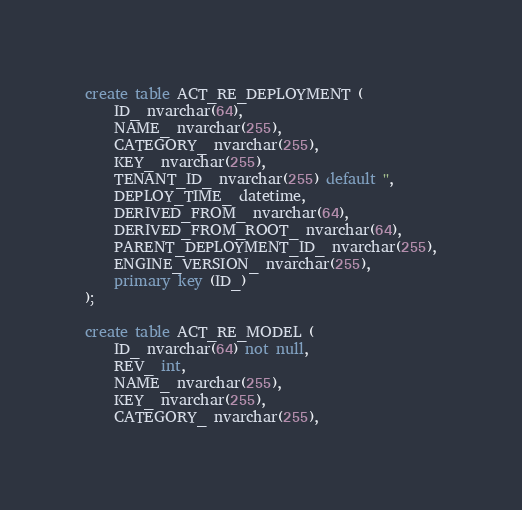<code> <loc_0><loc_0><loc_500><loc_500><_SQL_>create table ACT_RE_DEPLOYMENT (
    ID_ nvarchar(64),
    NAME_ nvarchar(255),
    CATEGORY_ nvarchar(255),
    KEY_ nvarchar(255),
    TENANT_ID_ nvarchar(255) default '',
    DEPLOY_TIME_ datetime,
    DERIVED_FROM_ nvarchar(64),
    DERIVED_FROM_ROOT_ nvarchar(64),
    PARENT_DEPLOYMENT_ID_ nvarchar(255),
    ENGINE_VERSION_ nvarchar(255),
    primary key (ID_)
);

create table ACT_RE_MODEL (
    ID_ nvarchar(64) not null,
    REV_ int,
    NAME_ nvarchar(255),
    KEY_ nvarchar(255),
    CATEGORY_ nvarchar(255),</code> 